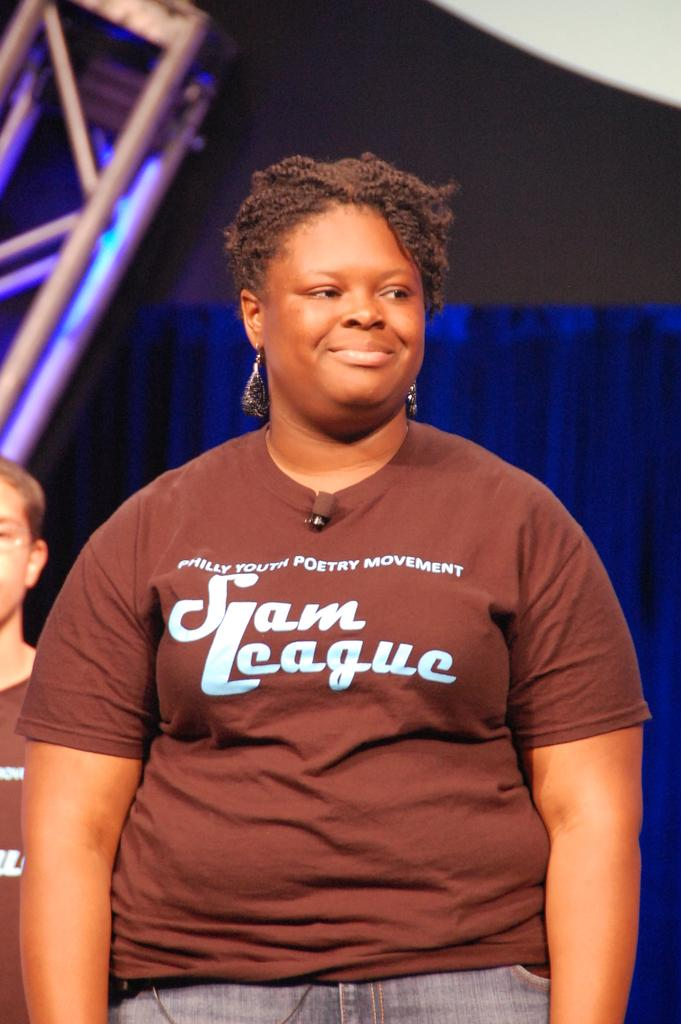<image>
Summarize the visual content of the image. A beautiful girl wears a shirt about a youth poetry movement. 